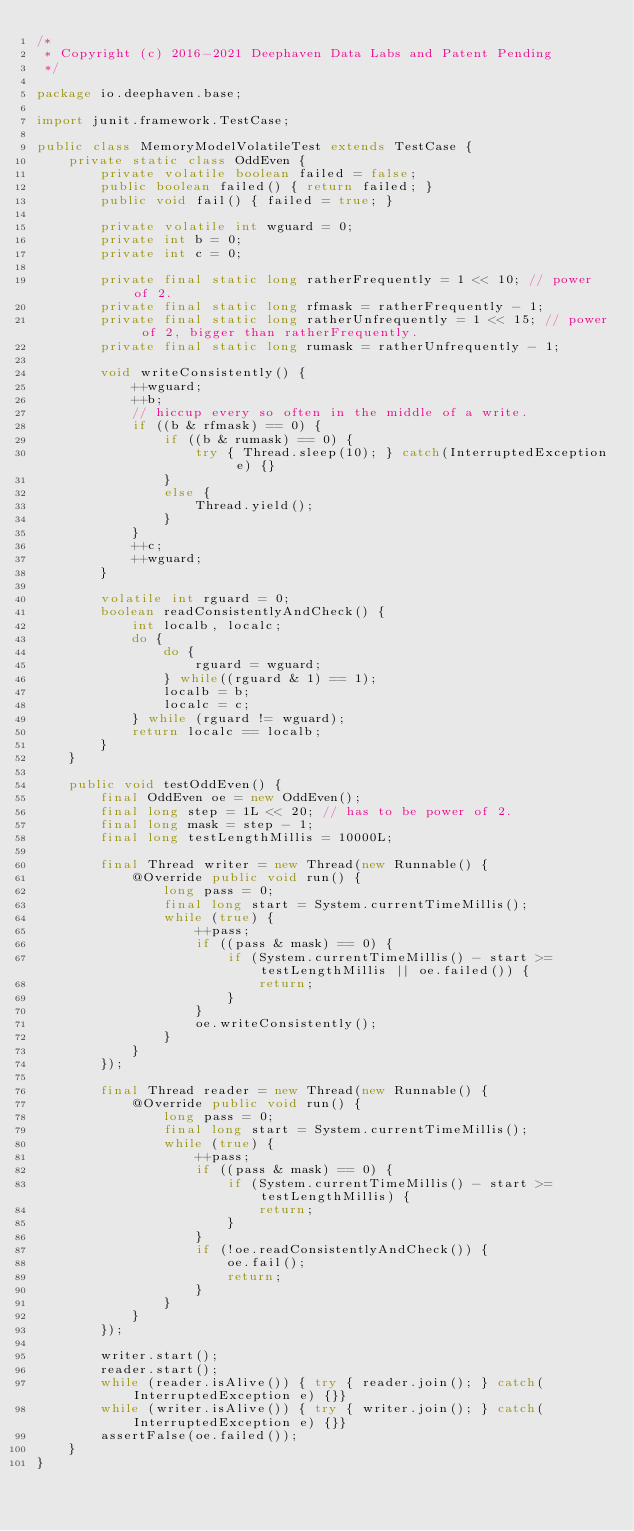<code> <loc_0><loc_0><loc_500><loc_500><_Java_>/*
 * Copyright (c) 2016-2021 Deephaven Data Labs and Patent Pending
 */

package io.deephaven.base;

import junit.framework.TestCase;

public class MemoryModelVolatileTest extends TestCase {
    private static class OddEven {
        private volatile boolean failed = false;
        public boolean failed() { return failed; }
        public void fail() { failed = true; }

        private volatile int wguard = 0;
        private int b = 0;
        private int c = 0;

        private final static long ratherFrequently = 1 << 10; // power of 2.
        private final static long rfmask = ratherFrequently - 1;
        private final static long ratherUnfrequently = 1 << 15; // power of 2, bigger than ratherFrequently.
        private final static long rumask = ratherUnfrequently - 1;

        void writeConsistently() {
            ++wguard;
            ++b;
            // hiccup every so often in the middle of a write.
            if ((b & rfmask) == 0) {
                if ((b & rumask) == 0) {
                    try { Thread.sleep(10); } catch(InterruptedException e) {}
                }
                else {
                    Thread.yield();
                }
            }
            ++c;
            ++wguard;
        }

        volatile int rguard = 0;
        boolean readConsistentlyAndCheck() {
            int localb, localc;
            do {
                do {
                    rguard = wguard;
                } while((rguard & 1) == 1);
                localb = b;
                localc = c;
            } while (rguard != wguard);
            return localc == localb;
        }
    }

    public void testOddEven() {
        final OddEven oe = new OddEven();
        final long step = 1L << 20; // has to be power of 2.
        final long mask = step - 1;
        final long testLengthMillis = 10000L;

        final Thread writer = new Thread(new Runnable() {
            @Override public void run() {
                long pass = 0;
                final long start = System.currentTimeMillis();
                while (true) {
                    ++pass;
                    if ((pass & mask) == 0) {
                        if (System.currentTimeMillis() - start >= testLengthMillis || oe.failed()) {
                            return;
                        }
                    }
                    oe.writeConsistently();
                }
            }
        });

        final Thread reader = new Thread(new Runnable() {
            @Override public void run() {
                long pass = 0;
                final long start = System.currentTimeMillis();
                while (true) {
                    ++pass;
                    if ((pass & mask) == 0) {
                        if (System.currentTimeMillis() - start >= testLengthMillis) {
                            return;
                        }
                    }
                    if (!oe.readConsistentlyAndCheck()) {
                        oe.fail();
                        return;
                    }
                }
            }
        });

        writer.start();
        reader.start();
        while (reader.isAlive()) { try { reader.join(); } catch(InterruptedException e) {}}
        while (writer.isAlive()) { try { writer.join(); } catch(InterruptedException e) {}}
        assertFalse(oe.failed());
    }
}
</code> 